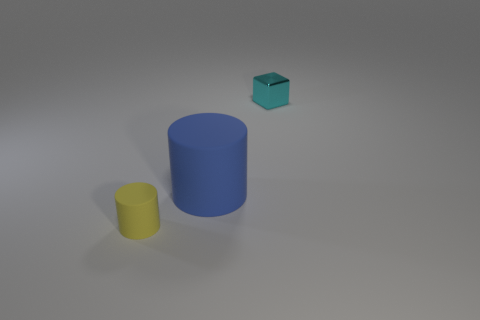Is there any other thing that is the same size as the blue object?
Your answer should be compact. No. How big is the rubber thing behind the thing in front of the matte thing right of the yellow rubber cylinder?
Provide a short and direct response. Large. What shape is the object that is the same size as the yellow matte cylinder?
Keep it short and to the point. Cube. Is there anything else that has the same material as the big blue cylinder?
Your answer should be very brief. Yes. How many objects are either matte things that are behind the small yellow cylinder or large matte cylinders?
Ensure brevity in your answer.  1. Are there any objects that are to the right of the tiny object to the right of the small object that is in front of the metal thing?
Your answer should be compact. No. What number of tiny green blocks are there?
Offer a very short reply. 0. What number of objects are either objects in front of the tiny metal cube or tiny things in front of the metal thing?
Your answer should be compact. 2. There is a thing that is behind the blue object; does it have the same size as the blue matte thing?
Give a very brief answer. No. There is another object that is the same shape as the big rubber thing; what is its size?
Your response must be concise. Small. 